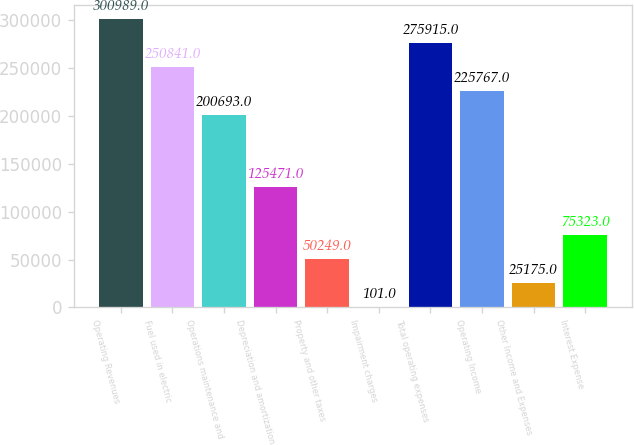<chart> <loc_0><loc_0><loc_500><loc_500><bar_chart><fcel>Operating Revenues<fcel>Fuel used in electric<fcel>Operations maintenance and<fcel>Depreciation and amortization<fcel>Property and other taxes<fcel>Impairment charges<fcel>Total operating expenses<fcel>Operating Income<fcel>Other Income and Expenses<fcel>Interest Expense<nl><fcel>300989<fcel>250841<fcel>200693<fcel>125471<fcel>50249<fcel>101<fcel>275915<fcel>225767<fcel>25175<fcel>75323<nl></chart> 